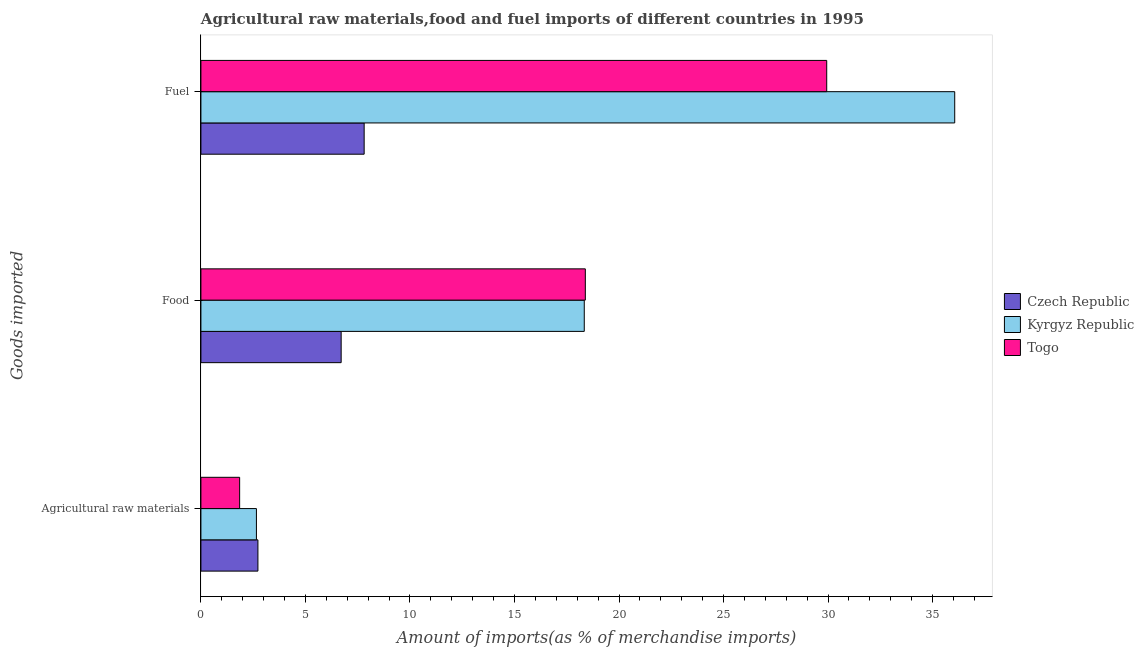What is the label of the 1st group of bars from the top?
Give a very brief answer. Fuel. What is the percentage of raw materials imports in Togo?
Keep it short and to the point. 1.85. Across all countries, what is the maximum percentage of raw materials imports?
Your response must be concise. 2.73. Across all countries, what is the minimum percentage of food imports?
Make the answer very short. 6.71. In which country was the percentage of raw materials imports maximum?
Give a very brief answer. Czech Republic. In which country was the percentage of raw materials imports minimum?
Your answer should be very brief. Togo. What is the total percentage of raw materials imports in the graph?
Keep it short and to the point. 7.23. What is the difference between the percentage of fuel imports in Togo and that in Kyrgyz Republic?
Your answer should be very brief. -6.12. What is the difference between the percentage of food imports in Kyrgyz Republic and the percentage of raw materials imports in Togo?
Provide a succinct answer. 16.48. What is the average percentage of food imports per country?
Offer a very short reply. 14.48. What is the difference between the percentage of raw materials imports and percentage of fuel imports in Togo?
Provide a short and direct response. -28.08. What is the ratio of the percentage of food imports in Czech Republic to that in Kyrgyz Republic?
Ensure brevity in your answer.  0.37. Is the percentage of food imports in Czech Republic less than that in Togo?
Your answer should be compact. Yes. Is the difference between the percentage of fuel imports in Kyrgyz Republic and Togo greater than the difference between the percentage of food imports in Kyrgyz Republic and Togo?
Give a very brief answer. Yes. What is the difference between the highest and the second highest percentage of fuel imports?
Your answer should be compact. 6.12. What is the difference between the highest and the lowest percentage of fuel imports?
Ensure brevity in your answer.  28.25. In how many countries, is the percentage of food imports greater than the average percentage of food imports taken over all countries?
Your answer should be very brief. 2. What does the 2nd bar from the top in Agricultural raw materials represents?
Offer a terse response. Kyrgyz Republic. What does the 1st bar from the bottom in Fuel represents?
Give a very brief answer. Czech Republic. Is it the case that in every country, the sum of the percentage of raw materials imports and percentage of food imports is greater than the percentage of fuel imports?
Keep it short and to the point. No. How many bars are there?
Provide a succinct answer. 9. How many countries are there in the graph?
Offer a very short reply. 3. What is the difference between two consecutive major ticks on the X-axis?
Offer a very short reply. 5. Are the values on the major ticks of X-axis written in scientific E-notation?
Your answer should be very brief. No. Does the graph contain grids?
Offer a very short reply. No. Where does the legend appear in the graph?
Offer a very short reply. Center right. How are the legend labels stacked?
Provide a short and direct response. Vertical. What is the title of the graph?
Make the answer very short. Agricultural raw materials,food and fuel imports of different countries in 1995. What is the label or title of the X-axis?
Make the answer very short. Amount of imports(as % of merchandise imports). What is the label or title of the Y-axis?
Your answer should be compact. Goods imported. What is the Amount of imports(as % of merchandise imports) in Czech Republic in Agricultural raw materials?
Ensure brevity in your answer.  2.73. What is the Amount of imports(as % of merchandise imports) of Kyrgyz Republic in Agricultural raw materials?
Your answer should be compact. 2.66. What is the Amount of imports(as % of merchandise imports) of Togo in Agricultural raw materials?
Your answer should be very brief. 1.85. What is the Amount of imports(as % of merchandise imports) of Czech Republic in Food?
Your answer should be very brief. 6.71. What is the Amount of imports(as % of merchandise imports) of Kyrgyz Republic in Food?
Give a very brief answer. 18.34. What is the Amount of imports(as % of merchandise imports) of Togo in Food?
Keep it short and to the point. 18.39. What is the Amount of imports(as % of merchandise imports) in Czech Republic in Fuel?
Your response must be concise. 7.81. What is the Amount of imports(as % of merchandise imports) of Kyrgyz Republic in Fuel?
Keep it short and to the point. 36.06. What is the Amount of imports(as % of merchandise imports) of Togo in Fuel?
Give a very brief answer. 29.93. Across all Goods imported, what is the maximum Amount of imports(as % of merchandise imports) in Czech Republic?
Offer a very short reply. 7.81. Across all Goods imported, what is the maximum Amount of imports(as % of merchandise imports) of Kyrgyz Republic?
Your answer should be compact. 36.06. Across all Goods imported, what is the maximum Amount of imports(as % of merchandise imports) in Togo?
Offer a very short reply. 29.93. Across all Goods imported, what is the minimum Amount of imports(as % of merchandise imports) of Czech Republic?
Your response must be concise. 2.73. Across all Goods imported, what is the minimum Amount of imports(as % of merchandise imports) in Kyrgyz Republic?
Your response must be concise. 2.66. Across all Goods imported, what is the minimum Amount of imports(as % of merchandise imports) in Togo?
Your answer should be compact. 1.85. What is the total Amount of imports(as % of merchandise imports) in Czech Republic in the graph?
Your answer should be very brief. 17.24. What is the total Amount of imports(as % of merchandise imports) in Kyrgyz Republic in the graph?
Your answer should be very brief. 57.05. What is the total Amount of imports(as % of merchandise imports) of Togo in the graph?
Offer a terse response. 50.17. What is the difference between the Amount of imports(as % of merchandise imports) in Czech Republic in Agricultural raw materials and that in Food?
Make the answer very short. -3.98. What is the difference between the Amount of imports(as % of merchandise imports) in Kyrgyz Republic in Agricultural raw materials and that in Food?
Provide a short and direct response. -15.68. What is the difference between the Amount of imports(as % of merchandise imports) of Togo in Agricultural raw materials and that in Food?
Make the answer very short. -16.54. What is the difference between the Amount of imports(as % of merchandise imports) of Czech Republic in Agricultural raw materials and that in Fuel?
Ensure brevity in your answer.  -5.08. What is the difference between the Amount of imports(as % of merchandise imports) in Kyrgyz Republic in Agricultural raw materials and that in Fuel?
Give a very brief answer. -33.4. What is the difference between the Amount of imports(as % of merchandise imports) of Togo in Agricultural raw materials and that in Fuel?
Your response must be concise. -28.08. What is the difference between the Amount of imports(as % of merchandise imports) in Czech Republic in Food and that in Fuel?
Offer a terse response. -1.1. What is the difference between the Amount of imports(as % of merchandise imports) in Kyrgyz Republic in Food and that in Fuel?
Your answer should be very brief. -17.72. What is the difference between the Amount of imports(as % of merchandise imports) in Togo in Food and that in Fuel?
Your answer should be very brief. -11.55. What is the difference between the Amount of imports(as % of merchandise imports) in Czech Republic in Agricultural raw materials and the Amount of imports(as % of merchandise imports) in Kyrgyz Republic in Food?
Provide a short and direct response. -15.61. What is the difference between the Amount of imports(as % of merchandise imports) of Czech Republic in Agricultural raw materials and the Amount of imports(as % of merchandise imports) of Togo in Food?
Your response must be concise. -15.66. What is the difference between the Amount of imports(as % of merchandise imports) of Kyrgyz Republic in Agricultural raw materials and the Amount of imports(as % of merchandise imports) of Togo in Food?
Offer a very short reply. -15.73. What is the difference between the Amount of imports(as % of merchandise imports) in Czech Republic in Agricultural raw materials and the Amount of imports(as % of merchandise imports) in Kyrgyz Republic in Fuel?
Give a very brief answer. -33.33. What is the difference between the Amount of imports(as % of merchandise imports) of Czech Republic in Agricultural raw materials and the Amount of imports(as % of merchandise imports) of Togo in Fuel?
Provide a succinct answer. -27.21. What is the difference between the Amount of imports(as % of merchandise imports) in Kyrgyz Republic in Agricultural raw materials and the Amount of imports(as % of merchandise imports) in Togo in Fuel?
Offer a very short reply. -27.28. What is the difference between the Amount of imports(as % of merchandise imports) of Czech Republic in Food and the Amount of imports(as % of merchandise imports) of Kyrgyz Republic in Fuel?
Offer a terse response. -29.35. What is the difference between the Amount of imports(as % of merchandise imports) in Czech Republic in Food and the Amount of imports(as % of merchandise imports) in Togo in Fuel?
Offer a very short reply. -23.23. What is the difference between the Amount of imports(as % of merchandise imports) in Kyrgyz Republic in Food and the Amount of imports(as % of merchandise imports) in Togo in Fuel?
Your answer should be compact. -11.6. What is the average Amount of imports(as % of merchandise imports) of Czech Republic per Goods imported?
Your answer should be compact. 5.75. What is the average Amount of imports(as % of merchandise imports) of Kyrgyz Republic per Goods imported?
Keep it short and to the point. 19.02. What is the average Amount of imports(as % of merchandise imports) of Togo per Goods imported?
Your response must be concise. 16.72. What is the difference between the Amount of imports(as % of merchandise imports) in Czech Republic and Amount of imports(as % of merchandise imports) in Kyrgyz Republic in Agricultural raw materials?
Provide a succinct answer. 0.07. What is the difference between the Amount of imports(as % of merchandise imports) of Czech Republic and Amount of imports(as % of merchandise imports) of Togo in Agricultural raw materials?
Your response must be concise. 0.87. What is the difference between the Amount of imports(as % of merchandise imports) in Kyrgyz Republic and Amount of imports(as % of merchandise imports) in Togo in Agricultural raw materials?
Keep it short and to the point. 0.8. What is the difference between the Amount of imports(as % of merchandise imports) in Czech Republic and Amount of imports(as % of merchandise imports) in Kyrgyz Republic in Food?
Ensure brevity in your answer.  -11.63. What is the difference between the Amount of imports(as % of merchandise imports) in Czech Republic and Amount of imports(as % of merchandise imports) in Togo in Food?
Offer a very short reply. -11.68. What is the difference between the Amount of imports(as % of merchandise imports) of Kyrgyz Republic and Amount of imports(as % of merchandise imports) of Togo in Food?
Give a very brief answer. -0.05. What is the difference between the Amount of imports(as % of merchandise imports) of Czech Republic and Amount of imports(as % of merchandise imports) of Kyrgyz Republic in Fuel?
Your answer should be very brief. -28.25. What is the difference between the Amount of imports(as % of merchandise imports) in Czech Republic and Amount of imports(as % of merchandise imports) in Togo in Fuel?
Offer a very short reply. -22.13. What is the difference between the Amount of imports(as % of merchandise imports) in Kyrgyz Republic and Amount of imports(as % of merchandise imports) in Togo in Fuel?
Provide a short and direct response. 6.12. What is the ratio of the Amount of imports(as % of merchandise imports) of Czech Republic in Agricultural raw materials to that in Food?
Provide a short and direct response. 0.41. What is the ratio of the Amount of imports(as % of merchandise imports) in Kyrgyz Republic in Agricultural raw materials to that in Food?
Your answer should be compact. 0.14. What is the ratio of the Amount of imports(as % of merchandise imports) in Togo in Agricultural raw materials to that in Food?
Give a very brief answer. 0.1. What is the ratio of the Amount of imports(as % of merchandise imports) of Czech Republic in Agricultural raw materials to that in Fuel?
Provide a short and direct response. 0.35. What is the ratio of the Amount of imports(as % of merchandise imports) of Kyrgyz Republic in Agricultural raw materials to that in Fuel?
Provide a succinct answer. 0.07. What is the ratio of the Amount of imports(as % of merchandise imports) in Togo in Agricultural raw materials to that in Fuel?
Offer a terse response. 0.06. What is the ratio of the Amount of imports(as % of merchandise imports) of Czech Republic in Food to that in Fuel?
Provide a succinct answer. 0.86. What is the ratio of the Amount of imports(as % of merchandise imports) of Kyrgyz Republic in Food to that in Fuel?
Provide a succinct answer. 0.51. What is the ratio of the Amount of imports(as % of merchandise imports) of Togo in Food to that in Fuel?
Give a very brief answer. 0.61. What is the difference between the highest and the second highest Amount of imports(as % of merchandise imports) in Czech Republic?
Offer a very short reply. 1.1. What is the difference between the highest and the second highest Amount of imports(as % of merchandise imports) of Kyrgyz Republic?
Ensure brevity in your answer.  17.72. What is the difference between the highest and the second highest Amount of imports(as % of merchandise imports) of Togo?
Your answer should be very brief. 11.55. What is the difference between the highest and the lowest Amount of imports(as % of merchandise imports) of Czech Republic?
Your answer should be compact. 5.08. What is the difference between the highest and the lowest Amount of imports(as % of merchandise imports) of Kyrgyz Republic?
Provide a short and direct response. 33.4. What is the difference between the highest and the lowest Amount of imports(as % of merchandise imports) of Togo?
Ensure brevity in your answer.  28.08. 